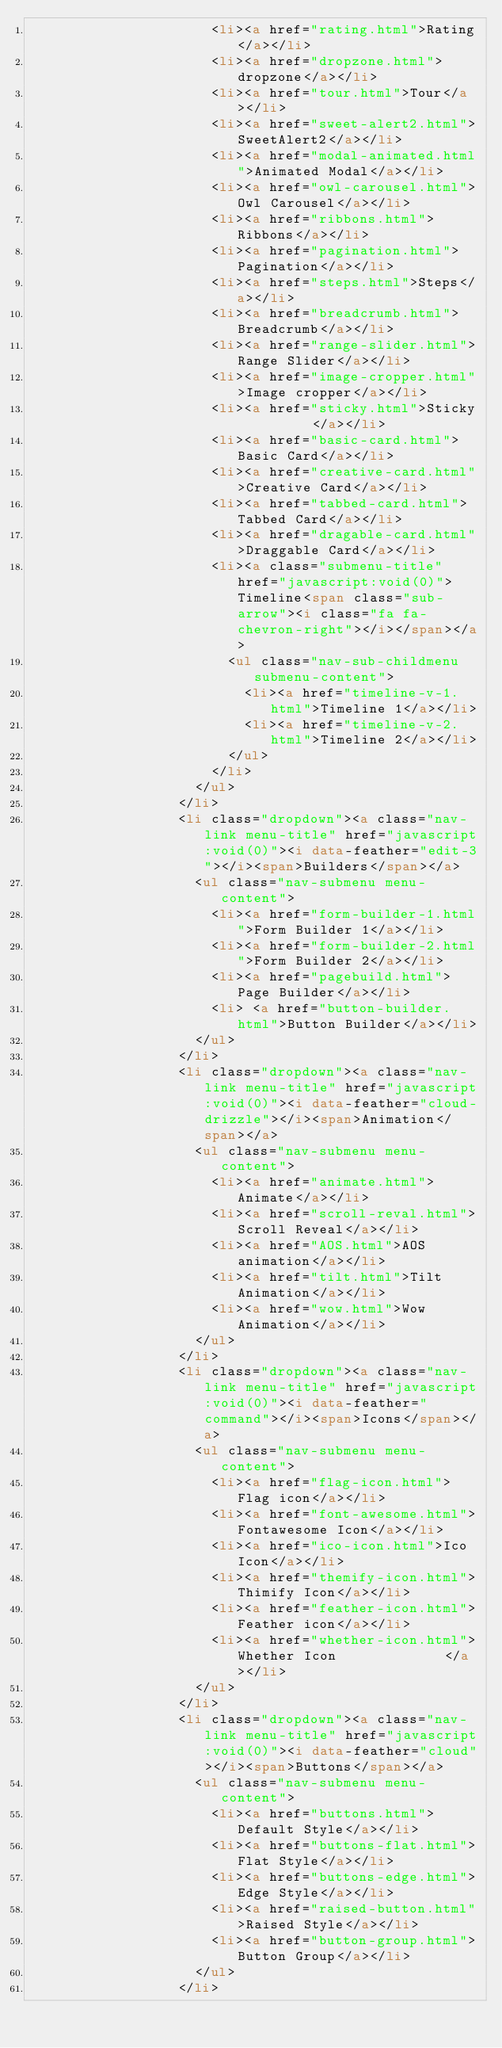Convert code to text. <code><loc_0><loc_0><loc_500><loc_500><_HTML_>                      <li><a href="rating.html">Rating</a></li>
                      <li><a href="dropzone.html">dropzone</a></li>
                      <li><a href="tour.html">Tour</a></li>
                      <li><a href="sweet-alert2.html">SweetAlert2</a></li>
                      <li><a href="modal-animated.html">Animated Modal</a></li>
                      <li><a href="owl-carousel.html">Owl Carousel</a></li>
                      <li><a href="ribbons.html">Ribbons</a></li>
                      <li><a href="pagination.html">Pagination</a></li>
                      <li><a href="steps.html">Steps</a></li>
                      <li><a href="breadcrumb.html">Breadcrumb</a></li>
                      <li><a href="range-slider.html">Range Slider</a></li>
                      <li><a href="image-cropper.html">Image cropper</a></li>
                      <li><a href="sticky.html">Sticky         </a></li>
                      <li><a href="basic-card.html">Basic Card</a></li>
                      <li><a href="creative-card.html">Creative Card</a></li>
                      <li><a href="tabbed-card.html">Tabbed Card</a></li>
                      <li><a href="dragable-card.html">Draggable Card</a></li>
                      <li><a class="submenu-title" href="javascript:void(0)">Timeline<span class="sub-arrow"><i class="fa fa-chevron-right"></i></span></a>
                        <ul class="nav-sub-childmenu submenu-content">
                          <li><a href="timeline-v-1.html">Timeline 1</a></li>
                          <li><a href="timeline-v-2.html">Timeline 2</a></li>
                        </ul>
                      </li>
                    </ul>
                  </li>
                  <li class="dropdown"><a class="nav-link menu-title" href="javascript:void(0)"><i data-feather="edit-3"></i><span>Builders</span></a>
                    <ul class="nav-submenu menu-content">
                      <li><a href="form-builder-1.html">Form Builder 1</a></li>
                      <li><a href="form-builder-2.html">Form Builder 2</a></li>
                      <li><a href="pagebuild.html">Page Builder</a></li>
                      <li> <a href="button-builder.html">Button Builder</a></li>
                    </ul>
                  </li>
                  <li class="dropdown"><a class="nav-link menu-title" href="javascript:void(0)"><i data-feather="cloud-drizzle"></i><span>Animation</span></a>
                    <ul class="nav-submenu menu-content">
                      <li><a href="animate.html">Animate</a></li>
                      <li><a href="scroll-reval.html">Scroll Reveal</a></li>
                      <li><a href="AOS.html">AOS animation</a></li>
                      <li><a href="tilt.html">Tilt Animation</a></li>
                      <li><a href="wow.html">Wow Animation</a></li>
                    </ul>
                  </li>
                  <li class="dropdown"><a class="nav-link menu-title" href="javascript:void(0)"><i data-feather="command"></i><span>Icons</span></a>
                    <ul class="nav-submenu menu-content">
                      <li><a href="flag-icon.html">Flag icon</a></li>
                      <li><a href="font-awesome.html">Fontawesome Icon</a></li>
                      <li><a href="ico-icon.html">Ico Icon</a></li>
                      <li><a href="themify-icon.html">Thimify Icon</a></li>
                      <li><a href="feather-icon.html">Feather icon</a></li>
                      <li><a href="whether-icon.html">Whether Icon             </a></li>
                    </ul>
                  </li>
                  <li class="dropdown"><a class="nav-link menu-title" href="javascript:void(0)"><i data-feather="cloud"></i><span>Buttons</span></a>
                    <ul class="nav-submenu menu-content">
                      <li><a href="buttons.html">Default Style</a></li>
                      <li><a href="buttons-flat.html">Flat Style</a></li>
                      <li><a href="buttons-edge.html">Edge Style</a></li>
                      <li><a href="raised-button.html">Raised Style</a></li>
                      <li><a href="button-group.html">Button Group</a></li>
                    </ul>
                  </li></code> 